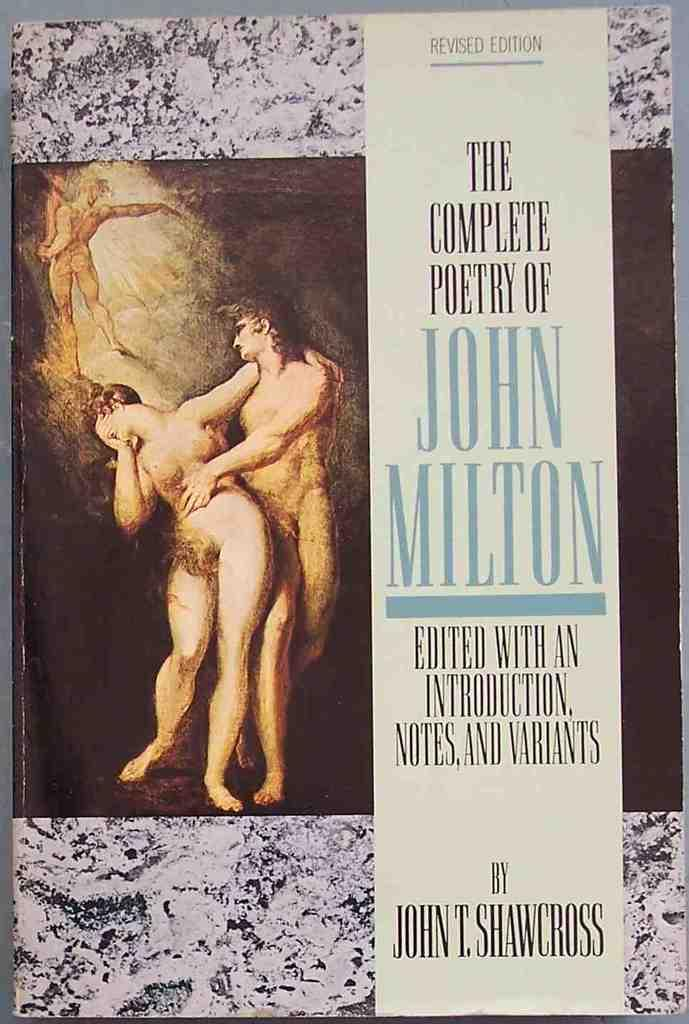<image>
Create a compact narrative representing the image presented. The title of the book is The Complete Poetry of John Milton. 